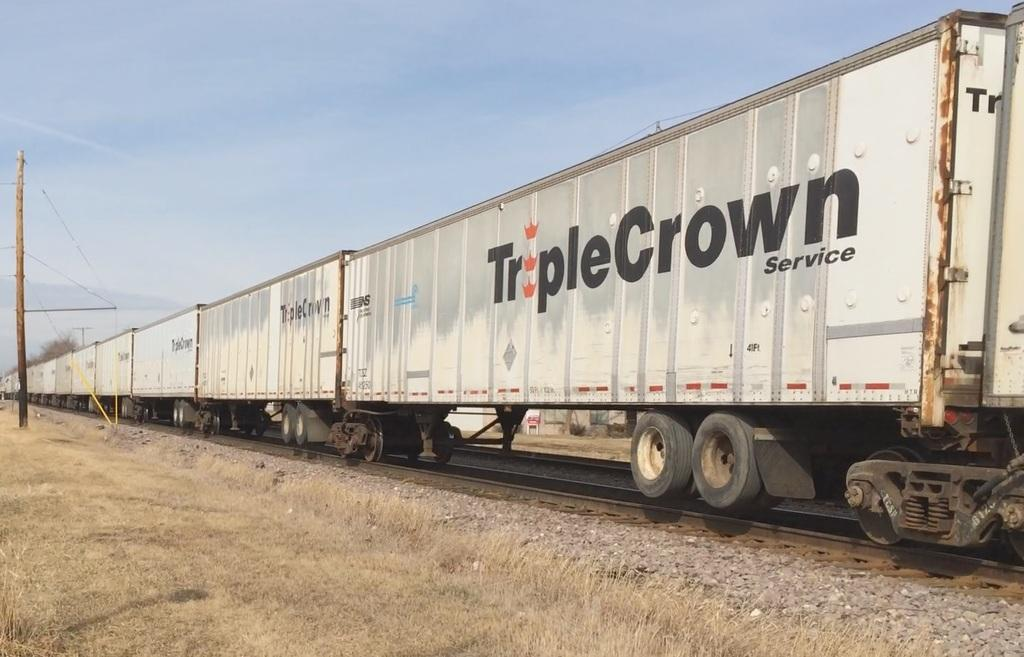<image>
Render a clear and concise summary of the photo. A long train or lorry with Triple Crown Service on the side. 